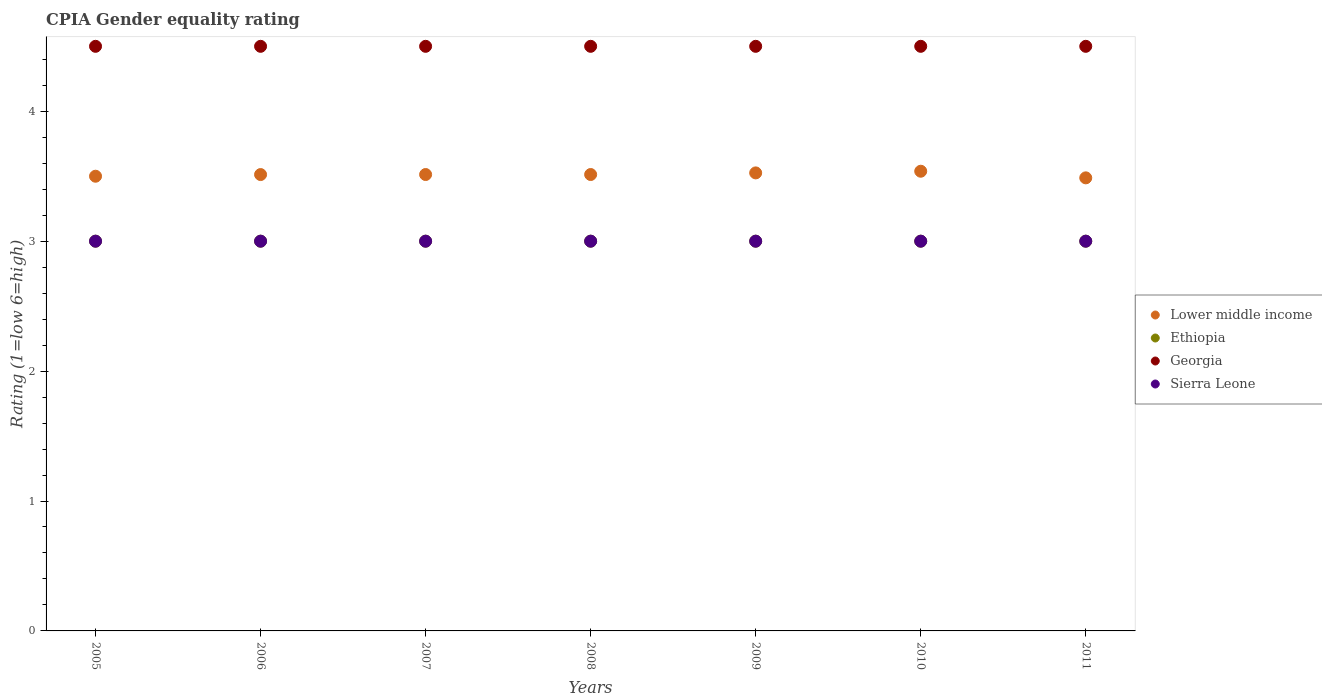Is the number of dotlines equal to the number of legend labels?
Offer a very short reply. Yes. What is the CPIA rating in Georgia in 2011?
Keep it short and to the point. 4.5. Across all years, what is the maximum CPIA rating in Georgia?
Your answer should be very brief. 4.5. In which year was the CPIA rating in Sierra Leone minimum?
Provide a succinct answer. 2005. What is the total CPIA rating in Georgia in the graph?
Give a very brief answer. 31.5. What is the difference between the CPIA rating in Lower middle income in 2005 and that in 2011?
Make the answer very short. 0.01. What is the difference between the CPIA rating in Lower middle income in 2006 and the CPIA rating in Sierra Leone in 2007?
Your response must be concise. 0.51. What is the average CPIA rating in Georgia per year?
Your answer should be compact. 4.5. In how many years, is the CPIA rating in Sierra Leone greater than 2.2?
Keep it short and to the point. 7. What is the ratio of the CPIA rating in Lower middle income in 2005 to that in 2011?
Give a very brief answer. 1. Is the CPIA rating in Georgia in 2007 less than that in 2011?
Your answer should be very brief. No. Is the difference between the CPIA rating in Sierra Leone in 2005 and 2010 greater than the difference between the CPIA rating in Lower middle income in 2005 and 2010?
Give a very brief answer. Yes. What is the difference between the highest and the lowest CPIA rating in Lower middle income?
Ensure brevity in your answer.  0.05. In how many years, is the CPIA rating in Ethiopia greater than the average CPIA rating in Ethiopia taken over all years?
Your response must be concise. 0. Is it the case that in every year, the sum of the CPIA rating in Sierra Leone and CPIA rating in Georgia  is greater than the CPIA rating in Ethiopia?
Ensure brevity in your answer.  Yes. Does the CPIA rating in Georgia monotonically increase over the years?
Ensure brevity in your answer.  No. Is the CPIA rating in Ethiopia strictly less than the CPIA rating in Sierra Leone over the years?
Your answer should be compact. No. How many dotlines are there?
Offer a terse response. 4. How many years are there in the graph?
Provide a succinct answer. 7. Where does the legend appear in the graph?
Ensure brevity in your answer.  Center right. How are the legend labels stacked?
Provide a short and direct response. Vertical. What is the title of the graph?
Your answer should be very brief. CPIA Gender equality rating. Does "Poland" appear as one of the legend labels in the graph?
Your response must be concise. No. What is the label or title of the X-axis?
Offer a very short reply. Years. What is the label or title of the Y-axis?
Offer a very short reply. Rating (1=low 6=high). What is the Rating (1=low 6=high) of Lower middle income in 2005?
Your answer should be very brief. 3.5. What is the Rating (1=low 6=high) of Georgia in 2005?
Offer a very short reply. 4.5. What is the Rating (1=low 6=high) of Sierra Leone in 2005?
Your answer should be compact. 3. What is the Rating (1=low 6=high) in Lower middle income in 2006?
Keep it short and to the point. 3.51. What is the Rating (1=low 6=high) in Ethiopia in 2006?
Your answer should be very brief. 3. What is the Rating (1=low 6=high) of Georgia in 2006?
Provide a short and direct response. 4.5. What is the Rating (1=low 6=high) of Lower middle income in 2007?
Provide a succinct answer. 3.51. What is the Rating (1=low 6=high) of Lower middle income in 2008?
Your answer should be compact. 3.51. What is the Rating (1=low 6=high) of Georgia in 2008?
Your answer should be very brief. 4.5. What is the Rating (1=low 6=high) of Sierra Leone in 2008?
Keep it short and to the point. 3. What is the Rating (1=low 6=high) in Lower middle income in 2009?
Offer a terse response. 3.53. What is the Rating (1=low 6=high) in Ethiopia in 2009?
Give a very brief answer. 3. What is the Rating (1=low 6=high) in Sierra Leone in 2009?
Give a very brief answer. 3. What is the Rating (1=low 6=high) in Lower middle income in 2010?
Give a very brief answer. 3.54. What is the Rating (1=low 6=high) in Lower middle income in 2011?
Your response must be concise. 3.49. What is the Rating (1=low 6=high) in Ethiopia in 2011?
Offer a terse response. 3. Across all years, what is the maximum Rating (1=low 6=high) of Lower middle income?
Provide a succinct answer. 3.54. Across all years, what is the maximum Rating (1=low 6=high) in Ethiopia?
Provide a short and direct response. 3. Across all years, what is the maximum Rating (1=low 6=high) in Sierra Leone?
Ensure brevity in your answer.  3. Across all years, what is the minimum Rating (1=low 6=high) of Lower middle income?
Provide a short and direct response. 3.49. What is the total Rating (1=low 6=high) in Lower middle income in the graph?
Offer a terse response. 24.59. What is the total Rating (1=low 6=high) of Georgia in the graph?
Make the answer very short. 31.5. What is the total Rating (1=low 6=high) in Sierra Leone in the graph?
Offer a terse response. 21. What is the difference between the Rating (1=low 6=high) of Lower middle income in 2005 and that in 2006?
Provide a short and direct response. -0.01. What is the difference between the Rating (1=low 6=high) of Ethiopia in 2005 and that in 2006?
Your answer should be compact. 0. What is the difference between the Rating (1=low 6=high) in Georgia in 2005 and that in 2006?
Provide a succinct answer. 0. What is the difference between the Rating (1=low 6=high) of Sierra Leone in 2005 and that in 2006?
Provide a short and direct response. 0. What is the difference between the Rating (1=low 6=high) in Lower middle income in 2005 and that in 2007?
Provide a succinct answer. -0.01. What is the difference between the Rating (1=low 6=high) in Sierra Leone in 2005 and that in 2007?
Your answer should be compact. 0. What is the difference between the Rating (1=low 6=high) in Lower middle income in 2005 and that in 2008?
Offer a terse response. -0.01. What is the difference between the Rating (1=low 6=high) of Ethiopia in 2005 and that in 2008?
Offer a very short reply. 0. What is the difference between the Rating (1=low 6=high) in Sierra Leone in 2005 and that in 2008?
Your answer should be very brief. 0. What is the difference between the Rating (1=low 6=high) in Lower middle income in 2005 and that in 2009?
Offer a very short reply. -0.03. What is the difference between the Rating (1=low 6=high) of Georgia in 2005 and that in 2009?
Provide a succinct answer. 0. What is the difference between the Rating (1=low 6=high) in Lower middle income in 2005 and that in 2010?
Provide a succinct answer. -0.04. What is the difference between the Rating (1=low 6=high) in Ethiopia in 2005 and that in 2010?
Offer a very short reply. 0. What is the difference between the Rating (1=low 6=high) in Georgia in 2005 and that in 2010?
Offer a terse response. 0. What is the difference between the Rating (1=low 6=high) in Lower middle income in 2005 and that in 2011?
Offer a very short reply. 0.01. What is the difference between the Rating (1=low 6=high) in Georgia in 2005 and that in 2011?
Your answer should be very brief. 0. What is the difference between the Rating (1=low 6=high) in Sierra Leone in 2005 and that in 2011?
Your response must be concise. 0. What is the difference between the Rating (1=low 6=high) of Lower middle income in 2006 and that in 2007?
Your answer should be compact. -0. What is the difference between the Rating (1=low 6=high) of Lower middle income in 2006 and that in 2008?
Your answer should be very brief. -0. What is the difference between the Rating (1=low 6=high) of Georgia in 2006 and that in 2008?
Make the answer very short. 0. What is the difference between the Rating (1=low 6=high) in Sierra Leone in 2006 and that in 2008?
Make the answer very short. 0. What is the difference between the Rating (1=low 6=high) in Lower middle income in 2006 and that in 2009?
Ensure brevity in your answer.  -0.01. What is the difference between the Rating (1=low 6=high) of Georgia in 2006 and that in 2009?
Provide a succinct answer. 0. What is the difference between the Rating (1=low 6=high) in Sierra Leone in 2006 and that in 2009?
Your answer should be very brief. 0. What is the difference between the Rating (1=low 6=high) in Lower middle income in 2006 and that in 2010?
Offer a terse response. -0.03. What is the difference between the Rating (1=low 6=high) in Ethiopia in 2006 and that in 2010?
Ensure brevity in your answer.  0. What is the difference between the Rating (1=low 6=high) in Sierra Leone in 2006 and that in 2010?
Offer a terse response. 0. What is the difference between the Rating (1=low 6=high) of Lower middle income in 2006 and that in 2011?
Make the answer very short. 0.03. What is the difference between the Rating (1=low 6=high) in Lower middle income in 2007 and that in 2008?
Make the answer very short. 0. What is the difference between the Rating (1=low 6=high) of Ethiopia in 2007 and that in 2008?
Offer a terse response. 0. What is the difference between the Rating (1=low 6=high) in Georgia in 2007 and that in 2008?
Offer a very short reply. 0. What is the difference between the Rating (1=low 6=high) of Sierra Leone in 2007 and that in 2008?
Make the answer very short. 0. What is the difference between the Rating (1=low 6=high) in Lower middle income in 2007 and that in 2009?
Keep it short and to the point. -0.01. What is the difference between the Rating (1=low 6=high) of Ethiopia in 2007 and that in 2009?
Make the answer very short. 0. What is the difference between the Rating (1=low 6=high) of Georgia in 2007 and that in 2009?
Offer a very short reply. 0. What is the difference between the Rating (1=low 6=high) in Sierra Leone in 2007 and that in 2009?
Provide a short and direct response. 0. What is the difference between the Rating (1=low 6=high) in Lower middle income in 2007 and that in 2010?
Your answer should be compact. -0.03. What is the difference between the Rating (1=low 6=high) in Ethiopia in 2007 and that in 2010?
Your answer should be very brief. 0. What is the difference between the Rating (1=low 6=high) in Georgia in 2007 and that in 2010?
Your answer should be compact. 0. What is the difference between the Rating (1=low 6=high) in Lower middle income in 2007 and that in 2011?
Offer a terse response. 0.03. What is the difference between the Rating (1=low 6=high) in Ethiopia in 2007 and that in 2011?
Offer a very short reply. 0. What is the difference between the Rating (1=low 6=high) in Sierra Leone in 2007 and that in 2011?
Your answer should be compact. 0. What is the difference between the Rating (1=low 6=high) in Lower middle income in 2008 and that in 2009?
Make the answer very short. -0.01. What is the difference between the Rating (1=low 6=high) in Ethiopia in 2008 and that in 2009?
Your response must be concise. 0. What is the difference between the Rating (1=low 6=high) of Lower middle income in 2008 and that in 2010?
Keep it short and to the point. -0.03. What is the difference between the Rating (1=low 6=high) in Ethiopia in 2008 and that in 2010?
Provide a succinct answer. 0. What is the difference between the Rating (1=low 6=high) in Sierra Leone in 2008 and that in 2010?
Provide a succinct answer. 0. What is the difference between the Rating (1=low 6=high) in Lower middle income in 2008 and that in 2011?
Keep it short and to the point. 0.03. What is the difference between the Rating (1=low 6=high) of Ethiopia in 2008 and that in 2011?
Provide a short and direct response. 0. What is the difference between the Rating (1=low 6=high) of Sierra Leone in 2008 and that in 2011?
Keep it short and to the point. 0. What is the difference between the Rating (1=low 6=high) in Lower middle income in 2009 and that in 2010?
Ensure brevity in your answer.  -0.01. What is the difference between the Rating (1=low 6=high) in Lower middle income in 2009 and that in 2011?
Your answer should be very brief. 0.04. What is the difference between the Rating (1=low 6=high) in Lower middle income in 2010 and that in 2011?
Your answer should be compact. 0.05. What is the difference between the Rating (1=low 6=high) in Georgia in 2010 and that in 2011?
Provide a short and direct response. 0. What is the difference between the Rating (1=low 6=high) of Sierra Leone in 2010 and that in 2011?
Provide a short and direct response. 0. What is the difference between the Rating (1=low 6=high) of Lower middle income in 2005 and the Rating (1=low 6=high) of Ethiopia in 2006?
Provide a succinct answer. 0.5. What is the difference between the Rating (1=low 6=high) of Lower middle income in 2005 and the Rating (1=low 6=high) of Georgia in 2006?
Provide a short and direct response. -1. What is the difference between the Rating (1=low 6=high) of Lower middle income in 2005 and the Rating (1=low 6=high) of Sierra Leone in 2006?
Offer a very short reply. 0.5. What is the difference between the Rating (1=low 6=high) in Ethiopia in 2005 and the Rating (1=low 6=high) in Georgia in 2006?
Offer a very short reply. -1.5. What is the difference between the Rating (1=low 6=high) of Ethiopia in 2005 and the Rating (1=low 6=high) of Sierra Leone in 2006?
Offer a terse response. 0. What is the difference between the Rating (1=low 6=high) of Georgia in 2005 and the Rating (1=low 6=high) of Sierra Leone in 2006?
Provide a short and direct response. 1.5. What is the difference between the Rating (1=low 6=high) of Ethiopia in 2005 and the Rating (1=low 6=high) of Georgia in 2007?
Give a very brief answer. -1.5. What is the difference between the Rating (1=low 6=high) in Ethiopia in 2005 and the Rating (1=low 6=high) in Sierra Leone in 2007?
Your answer should be very brief. 0. What is the difference between the Rating (1=low 6=high) of Georgia in 2005 and the Rating (1=low 6=high) of Sierra Leone in 2007?
Your response must be concise. 1.5. What is the difference between the Rating (1=low 6=high) of Lower middle income in 2005 and the Rating (1=low 6=high) of Ethiopia in 2008?
Keep it short and to the point. 0.5. What is the difference between the Rating (1=low 6=high) in Lower middle income in 2005 and the Rating (1=low 6=high) in Georgia in 2008?
Offer a very short reply. -1. What is the difference between the Rating (1=low 6=high) in Lower middle income in 2005 and the Rating (1=low 6=high) in Sierra Leone in 2008?
Offer a very short reply. 0.5. What is the difference between the Rating (1=low 6=high) of Ethiopia in 2005 and the Rating (1=low 6=high) of Sierra Leone in 2008?
Offer a terse response. 0. What is the difference between the Rating (1=low 6=high) in Georgia in 2005 and the Rating (1=low 6=high) in Sierra Leone in 2008?
Offer a very short reply. 1.5. What is the difference between the Rating (1=low 6=high) of Lower middle income in 2005 and the Rating (1=low 6=high) of Ethiopia in 2009?
Provide a short and direct response. 0.5. What is the difference between the Rating (1=low 6=high) of Lower middle income in 2005 and the Rating (1=low 6=high) of Georgia in 2009?
Keep it short and to the point. -1. What is the difference between the Rating (1=low 6=high) in Ethiopia in 2005 and the Rating (1=low 6=high) in Georgia in 2009?
Provide a short and direct response. -1.5. What is the difference between the Rating (1=low 6=high) in Ethiopia in 2005 and the Rating (1=low 6=high) in Sierra Leone in 2009?
Your answer should be compact. 0. What is the difference between the Rating (1=low 6=high) in Georgia in 2005 and the Rating (1=low 6=high) in Sierra Leone in 2009?
Your response must be concise. 1.5. What is the difference between the Rating (1=low 6=high) in Lower middle income in 2005 and the Rating (1=low 6=high) in Sierra Leone in 2010?
Offer a terse response. 0.5. What is the difference between the Rating (1=low 6=high) in Lower middle income in 2005 and the Rating (1=low 6=high) in Georgia in 2011?
Provide a short and direct response. -1. What is the difference between the Rating (1=low 6=high) of Lower middle income in 2005 and the Rating (1=low 6=high) of Sierra Leone in 2011?
Keep it short and to the point. 0.5. What is the difference between the Rating (1=low 6=high) of Ethiopia in 2005 and the Rating (1=low 6=high) of Georgia in 2011?
Ensure brevity in your answer.  -1.5. What is the difference between the Rating (1=low 6=high) in Ethiopia in 2005 and the Rating (1=low 6=high) in Sierra Leone in 2011?
Keep it short and to the point. 0. What is the difference between the Rating (1=low 6=high) in Lower middle income in 2006 and the Rating (1=low 6=high) in Ethiopia in 2007?
Keep it short and to the point. 0.51. What is the difference between the Rating (1=low 6=high) in Lower middle income in 2006 and the Rating (1=low 6=high) in Georgia in 2007?
Offer a very short reply. -0.99. What is the difference between the Rating (1=low 6=high) in Lower middle income in 2006 and the Rating (1=low 6=high) in Sierra Leone in 2007?
Give a very brief answer. 0.51. What is the difference between the Rating (1=low 6=high) of Ethiopia in 2006 and the Rating (1=low 6=high) of Georgia in 2007?
Make the answer very short. -1.5. What is the difference between the Rating (1=low 6=high) of Ethiopia in 2006 and the Rating (1=low 6=high) of Sierra Leone in 2007?
Provide a succinct answer. 0. What is the difference between the Rating (1=low 6=high) of Georgia in 2006 and the Rating (1=low 6=high) of Sierra Leone in 2007?
Keep it short and to the point. 1.5. What is the difference between the Rating (1=low 6=high) of Lower middle income in 2006 and the Rating (1=low 6=high) of Ethiopia in 2008?
Provide a short and direct response. 0.51. What is the difference between the Rating (1=low 6=high) of Lower middle income in 2006 and the Rating (1=low 6=high) of Georgia in 2008?
Provide a short and direct response. -0.99. What is the difference between the Rating (1=low 6=high) of Lower middle income in 2006 and the Rating (1=low 6=high) of Sierra Leone in 2008?
Your answer should be very brief. 0.51. What is the difference between the Rating (1=low 6=high) of Ethiopia in 2006 and the Rating (1=low 6=high) of Georgia in 2008?
Your response must be concise. -1.5. What is the difference between the Rating (1=low 6=high) in Ethiopia in 2006 and the Rating (1=low 6=high) in Sierra Leone in 2008?
Offer a terse response. 0. What is the difference between the Rating (1=low 6=high) of Lower middle income in 2006 and the Rating (1=low 6=high) of Ethiopia in 2009?
Your response must be concise. 0.51. What is the difference between the Rating (1=low 6=high) of Lower middle income in 2006 and the Rating (1=low 6=high) of Georgia in 2009?
Offer a terse response. -0.99. What is the difference between the Rating (1=low 6=high) of Lower middle income in 2006 and the Rating (1=low 6=high) of Sierra Leone in 2009?
Offer a very short reply. 0.51. What is the difference between the Rating (1=low 6=high) of Ethiopia in 2006 and the Rating (1=low 6=high) of Georgia in 2009?
Your response must be concise. -1.5. What is the difference between the Rating (1=low 6=high) of Lower middle income in 2006 and the Rating (1=low 6=high) of Ethiopia in 2010?
Provide a succinct answer. 0.51. What is the difference between the Rating (1=low 6=high) of Lower middle income in 2006 and the Rating (1=low 6=high) of Georgia in 2010?
Offer a terse response. -0.99. What is the difference between the Rating (1=low 6=high) of Lower middle income in 2006 and the Rating (1=low 6=high) of Sierra Leone in 2010?
Your answer should be compact. 0.51. What is the difference between the Rating (1=low 6=high) of Georgia in 2006 and the Rating (1=low 6=high) of Sierra Leone in 2010?
Give a very brief answer. 1.5. What is the difference between the Rating (1=low 6=high) in Lower middle income in 2006 and the Rating (1=low 6=high) in Ethiopia in 2011?
Make the answer very short. 0.51. What is the difference between the Rating (1=low 6=high) of Lower middle income in 2006 and the Rating (1=low 6=high) of Georgia in 2011?
Make the answer very short. -0.99. What is the difference between the Rating (1=low 6=high) in Lower middle income in 2006 and the Rating (1=low 6=high) in Sierra Leone in 2011?
Make the answer very short. 0.51. What is the difference between the Rating (1=low 6=high) of Ethiopia in 2006 and the Rating (1=low 6=high) of Georgia in 2011?
Your response must be concise. -1.5. What is the difference between the Rating (1=low 6=high) in Ethiopia in 2006 and the Rating (1=low 6=high) in Sierra Leone in 2011?
Offer a very short reply. 0. What is the difference between the Rating (1=low 6=high) of Georgia in 2006 and the Rating (1=low 6=high) of Sierra Leone in 2011?
Your response must be concise. 1.5. What is the difference between the Rating (1=low 6=high) in Lower middle income in 2007 and the Rating (1=low 6=high) in Ethiopia in 2008?
Keep it short and to the point. 0.51. What is the difference between the Rating (1=low 6=high) in Lower middle income in 2007 and the Rating (1=low 6=high) in Georgia in 2008?
Ensure brevity in your answer.  -0.99. What is the difference between the Rating (1=low 6=high) of Lower middle income in 2007 and the Rating (1=low 6=high) of Sierra Leone in 2008?
Ensure brevity in your answer.  0.51. What is the difference between the Rating (1=low 6=high) of Georgia in 2007 and the Rating (1=low 6=high) of Sierra Leone in 2008?
Offer a terse response. 1.5. What is the difference between the Rating (1=low 6=high) of Lower middle income in 2007 and the Rating (1=low 6=high) of Ethiopia in 2009?
Your response must be concise. 0.51. What is the difference between the Rating (1=low 6=high) in Lower middle income in 2007 and the Rating (1=low 6=high) in Georgia in 2009?
Provide a short and direct response. -0.99. What is the difference between the Rating (1=low 6=high) of Lower middle income in 2007 and the Rating (1=low 6=high) of Sierra Leone in 2009?
Your answer should be very brief. 0.51. What is the difference between the Rating (1=low 6=high) of Lower middle income in 2007 and the Rating (1=low 6=high) of Ethiopia in 2010?
Keep it short and to the point. 0.51. What is the difference between the Rating (1=low 6=high) in Lower middle income in 2007 and the Rating (1=low 6=high) in Georgia in 2010?
Make the answer very short. -0.99. What is the difference between the Rating (1=low 6=high) in Lower middle income in 2007 and the Rating (1=low 6=high) in Sierra Leone in 2010?
Ensure brevity in your answer.  0.51. What is the difference between the Rating (1=low 6=high) in Ethiopia in 2007 and the Rating (1=low 6=high) in Georgia in 2010?
Your answer should be very brief. -1.5. What is the difference between the Rating (1=low 6=high) in Georgia in 2007 and the Rating (1=low 6=high) in Sierra Leone in 2010?
Make the answer very short. 1.5. What is the difference between the Rating (1=low 6=high) in Lower middle income in 2007 and the Rating (1=low 6=high) in Ethiopia in 2011?
Offer a terse response. 0.51. What is the difference between the Rating (1=low 6=high) of Lower middle income in 2007 and the Rating (1=low 6=high) of Georgia in 2011?
Provide a short and direct response. -0.99. What is the difference between the Rating (1=low 6=high) in Lower middle income in 2007 and the Rating (1=low 6=high) in Sierra Leone in 2011?
Provide a short and direct response. 0.51. What is the difference between the Rating (1=low 6=high) of Ethiopia in 2007 and the Rating (1=low 6=high) of Georgia in 2011?
Your response must be concise. -1.5. What is the difference between the Rating (1=low 6=high) of Ethiopia in 2007 and the Rating (1=low 6=high) of Sierra Leone in 2011?
Make the answer very short. 0. What is the difference between the Rating (1=low 6=high) in Georgia in 2007 and the Rating (1=low 6=high) in Sierra Leone in 2011?
Provide a short and direct response. 1.5. What is the difference between the Rating (1=low 6=high) in Lower middle income in 2008 and the Rating (1=low 6=high) in Ethiopia in 2009?
Ensure brevity in your answer.  0.51. What is the difference between the Rating (1=low 6=high) of Lower middle income in 2008 and the Rating (1=low 6=high) of Georgia in 2009?
Keep it short and to the point. -0.99. What is the difference between the Rating (1=low 6=high) of Lower middle income in 2008 and the Rating (1=low 6=high) of Sierra Leone in 2009?
Keep it short and to the point. 0.51. What is the difference between the Rating (1=low 6=high) of Ethiopia in 2008 and the Rating (1=low 6=high) of Georgia in 2009?
Provide a succinct answer. -1.5. What is the difference between the Rating (1=low 6=high) of Ethiopia in 2008 and the Rating (1=low 6=high) of Sierra Leone in 2009?
Keep it short and to the point. 0. What is the difference between the Rating (1=low 6=high) of Lower middle income in 2008 and the Rating (1=low 6=high) of Ethiopia in 2010?
Provide a succinct answer. 0.51. What is the difference between the Rating (1=low 6=high) of Lower middle income in 2008 and the Rating (1=low 6=high) of Georgia in 2010?
Offer a terse response. -0.99. What is the difference between the Rating (1=low 6=high) in Lower middle income in 2008 and the Rating (1=low 6=high) in Sierra Leone in 2010?
Keep it short and to the point. 0.51. What is the difference between the Rating (1=low 6=high) in Georgia in 2008 and the Rating (1=low 6=high) in Sierra Leone in 2010?
Offer a terse response. 1.5. What is the difference between the Rating (1=low 6=high) in Lower middle income in 2008 and the Rating (1=low 6=high) in Ethiopia in 2011?
Give a very brief answer. 0.51. What is the difference between the Rating (1=low 6=high) of Lower middle income in 2008 and the Rating (1=low 6=high) of Georgia in 2011?
Offer a terse response. -0.99. What is the difference between the Rating (1=low 6=high) of Lower middle income in 2008 and the Rating (1=low 6=high) of Sierra Leone in 2011?
Keep it short and to the point. 0.51. What is the difference between the Rating (1=low 6=high) of Lower middle income in 2009 and the Rating (1=low 6=high) of Ethiopia in 2010?
Your response must be concise. 0.53. What is the difference between the Rating (1=low 6=high) in Lower middle income in 2009 and the Rating (1=low 6=high) in Georgia in 2010?
Provide a succinct answer. -0.97. What is the difference between the Rating (1=low 6=high) of Lower middle income in 2009 and the Rating (1=low 6=high) of Sierra Leone in 2010?
Provide a short and direct response. 0.53. What is the difference between the Rating (1=low 6=high) of Ethiopia in 2009 and the Rating (1=low 6=high) of Georgia in 2010?
Ensure brevity in your answer.  -1.5. What is the difference between the Rating (1=low 6=high) of Georgia in 2009 and the Rating (1=low 6=high) of Sierra Leone in 2010?
Your answer should be compact. 1.5. What is the difference between the Rating (1=low 6=high) in Lower middle income in 2009 and the Rating (1=low 6=high) in Ethiopia in 2011?
Keep it short and to the point. 0.53. What is the difference between the Rating (1=low 6=high) in Lower middle income in 2009 and the Rating (1=low 6=high) in Georgia in 2011?
Keep it short and to the point. -0.97. What is the difference between the Rating (1=low 6=high) of Lower middle income in 2009 and the Rating (1=low 6=high) of Sierra Leone in 2011?
Keep it short and to the point. 0.53. What is the difference between the Rating (1=low 6=high) in Ethiopia in 2009 and the Rating (1=low 6=high) in Georgia in 2011?
Keep it short and to the point. -1.5. What is the difference between the Rating (1=low 6=high) in Lower middle income in 2010 and the Rating (1=low 6=high) in Ethiopia in 2011?
Your response must be concise. 0.54. What is the difference between the Rating (1=low 6=high) of Lower middle income in 2010 and the Rating (1=low 6=high) of Georgia in 2011?
Your answer should be very brief. -0.96. What is the difference between the Rating (1=low 6=high) in Lower middle income in 2010 and the Rating (1=low 6=high) in Sierra Leone in 2011?
Provide a short and direct response. 0.54. What is the difference between the Rating (1=low 6=high) in Georgia in 2010 and the Rating (1=low 6=high) in Sierra Leone in 2011?
Your answer should be compact. 1.5. What is the average Rating (1=low 6=high) in Lower middle income per year?
Your answer should be very brief. 3.51. What is the average Rating (1=low 6=high) in Ethiopia per year?
Your answer should be very brief. 3. What is the average Rating (1=low 6=high) in Georgia per year?
Your answer should be very brief. 4.5. In the year 2005, what is the difference between the Rating (1=low 6=high) in Lower middle income and Rating (1=low 6=high) in Ethiopia?
Ensure brevity in your answer.  0.5. In the year 2005, what is the difference between the Rating (1=low 6=high) of Lower middle income and Rating (1=low 6=high) of Georgia?
Provide a succinct answer. -1. In the year 2005, what is the difference between the Rating (1=low 6=high) of Lower middle income and Rating (1=low 6=high) of Sierra Leone?
Offer a terse response. 0.5. In the year 2005, what is the difference between the Rating (1=low 6=high) of Ethiopia and Rating (1=low 6=high) of Sierra Leone?
Offer a very short reply. 0. In the year 2006, what is the difference between the Rating (1=low 6=high) in Lower middle income and Rating (1=low 6=high) in Ethiopia?
Your response must be concise. 0.51. In the year 2006, what is the difference between the Rating (1=low 6=high) in Lower middle income and Rating (1=low 6=high) in Georgia?
Give a very brief answer. -0.99. In the year 2006, what is the difference between the Rating (1=low 6=high) of Lower middle income and Rating (1=low 6=high) of Sierra Leone?
Your answer should be compact. 0.51. In the year 2006, what is the difference between the Rating (1=low 6=high) in Ethiopia and Rating (1=low 6=high) in Georgia?
Offer a very short reply. -1.5. In the year 2006, what is the difference between the Rating (1=low 6=high) of Ethiopia and Rating (1=low 6=high) of Sierra Leone?
Your answer should be compact. 0. In the year 2007, what is the difference between the Rating (1=low 6=high) in Lower middle income and Rating (1=low 6=high) in Ethiopia?
Provide a succinct answer. 0.51. In the year 2007, what is the difference between the Rating (1=low 6=high) of Lower middle income and Rating (1=low 6=high) of Georgia?
Make the answer very short. -0.99. In the year 2007, what is the difference between the Rating (1=low 6=high) of Lower middle income and Rating (1=low 6=high) of Sierra Leone?
Your answer should be compact. 0.51. In the year 2007, what is the difference between the Rating (1=low 6=high) in Ethiopia and Rating (1=low 6=high) in Georgia?
Your response must be concise. -1.5. In the year 2007, what is the difference between the Rating (1=low 6=high) of Georgia and Rating (1=low 6=high) of Sierra Leone?
Make the answer very short. 1.5. In the year 2008, what is the difference between the Rating (1=low 6=high) of Lower middle income and Rating (1=low 6=high) of Ethiopia?
Provide a short and direct response. 0.51. In the year 2008, what is the difference between the Rating (1=low 6=high) of Lower middle income and Rating (1=low 6=high) of Georgia?
Make the answer very short. -0.99. In the year 2008, what is the difference between the Rating (1=low 6=high) in Lower middle income and Rating (1=low 6=high) in Sierra Leone?
Provide a short and direct response. 0.51. In the year 2008, what is the difference between the Rating (1=low 6=high) in Georgia and Rating (1=low 6=high) in Sierra Leone?
Make the answer very short. 1.5. In the year 2009, what is the difference between the Rating (1=low 6=high) in Lower middle income and Rating (1=low 6=high) in Ethiopia?
Your answer should be compact. 0.53. In the year 2009, what is the difference between the Rating (1=low 6=high) in Lower middle income and Rating (1=low 6=high) in Georgia?
Your answer should be very brief. -0.97. In the year 2009, what is the difference between the Rating (1=low 6=high) of Lower middle income and Rating (1=low 6=high) of Sierra Leone?
Offer a terse response. 0.53. In the year 2009, what is the difference between the Rating (1=low 6=high) of Ethiopia and Rating (1=low 6=high) of Georgia?
Your answer should be compact. -1.5. In the year 2009, what is the difference between the Rating (1=low 6=high) in Ethiopia and Rating (1=low 6=high) in Sierra Leone?
Your response must be concise. 0. In the year 2009, what is the difference between the Rating (1=low 6=high) in Georgia and Rating (1=low 6=high) in Sierra Leone?
Your answer should be very brief. 1.5. In the year 2010, what is the difference between the Rating (1=low 6=high) of Lower middle income and Rating (1=low 6=high) of Ethiopia?
Keep it short and to the point. 0.54. In the year 2010, what is the difference between the Rating (1=low 6=high) in Lower middle income and Rating (1=low 6=high) in Georgia?
Make the answer very short. -0.96. In the year 2010, what is the difference between the Rating (1=low 6=high) in Lower middle income and Rating (1=low 6=high) in Sierra Leone?
Ensure brevity in your answer.  0.54. In the year 2010, what is the difference between the Rating (1=low 6=high) in Ethiopia and Rating (1=low 6=high) in Georgia?
Provide a short and direct response. -1.5. In the year 2010, what is the difference between the Rating (1=low 6=high) of Ethiopia and Rating (1=low 6=high) of Sierra Leone?
Offer a very short reply. 0. In the year 2011, what is the difference between the Rating (1=low 6=high) of Lower middle income and Rating (1=low 6=high) of Ethiopia?
Make the answer very short. 0.49. In the year 2011, what is the difference between the Rating (1=low 6=high) in Lower middle income and Rating (1=low 6=high) in Georgia?
Provide a short and direct response. -1.01. In the year 2011, what is the difference between the Rating (1=low 6=high) in Lower middle income and Rating (1=low 6=high) in Sierra Leone?
Give a very brief answer. 0.49. In the year 2011, what is the difference between the Rating (1=low 6=high) of Ethiopia and Rating (1=low 6=high) of Sierra Leone?
Provide a short and direct response. 0. What is the ratio of the Rating (1=low 6=high) in Lower middle income in 2005 to that in 2006?
Offer a very short reply. 1. What is the ratio of the Rating (1=low 6=high) in Ethiopia in 2005 to that in 2006?
Offer a very short reply. 1. What is the ratio of the Rating (1=low 6=high) of Georgia in 2005 to that in 2006?
Keep it short and to the point. 1. What is the ratio of the Rating (1=low 6=high) of Sierra Leone in 2005 to that in 2006?
Your answer should be very brief. 1. What is the ratio of the Rating (1=low 6=high) in Lower middle income in 2005 to that in 2007?
Ensure brevity in your answer.  1. What is the ratio of the Rating (1=low 6=high) of Ethiopia in 2005 to that in 2007?
Offer a very short reply. 1. What is the ratio of the Rating (1=low 6=high) of Georgia in 2005 to that in 2007?
Your answer should be compact. 1. What is the ratio of the Rating (1=low 6=high) of Ethiopia in 2005 to that in 2008?
Your answer should be very brief. 1. What is the ratio of the Rating (1=low 6=high) in Sierra Leone in 2005 to that in 2008?
Your answer should be compact. 1. What is the ratio of the Rating (1=low 6=high) of Ethiopia in 2005 to that in 2009?
Give a very brief answer. 1. What is the ratio of the Rating (1=low 6=high) of Georgia in 2005 to that in 2009?
Your response must be concise. 1. What is the ratio of the Rating (1=low 6=high) of Sierra Leone in 2005 to that in 2009?
Your answer should be compact. 1. What is the ratio of the Rating (1=low 6=high) of Lower middle income in 2005 to that in 2010?
Offer a very short reply. 0.99. What is the ratio of the Rating (1=low 6=high) in Sierra Leone in 2005 to that in 2010?
Provide a short and direct response. 1. What is the ratio of the Rating (1=low 6=high) in Lower middle income in 2005 to that in 2011?
Provide a succinct answer. 1. What is the ratio of the Rating (1=low 6=high) of Georgia in 2005 to that in 2011?
Offer a terse response. 1. What is the ratio of the Rating (1=low 6=high) of Sierra Leone in 2005 to that in 2011?
Your answer should be compact. 1. What is the ratio of the Rating (1=low 6=high) in Georgia in 2006 to that in 2007?
Your answer should be very brief. 1. What is the ratio of the Rating (1=low 6=high) of Sierra Leone in 2006 to that in 2007?
Your answer should be very brief. 1. What is the ratio of the Rating (1=low 6=high) in Lower middle income in 2006 to that in 2008?
Keep it short and to the point. 1. What is the ratio of the Rating (1=low 6=high) of Ethiopia in 2006 to that in 2008?
Provide a succinct answer. 1. What is the ratio of the Rating (1=low 6=high) in Sierra Leone in 2006 to that in 2008?
Provide a succinct answer. 1. What is the ratio of the Rating (1=low 6=high) of Lower middle income in 2006 to that in 2009?
Your response must be concise. 1. What is the ratio of the Rating (1=low 6=high) in Ethiopia in 2006 to that in 2009?
Provide a succinct answer. 1. What is the ratio of the Rating (1=low 6=high) of Georgia in 2006 to that in 2009?
Your answer should be very brief. 1. What is the ratio of the Rating (1=low 6=high) in Sierra Leone in 2006 to that in 2009?
Your answer should be compact. 1. What is the ratio of the Rating (1=low 6=high) in Lower middle income in 2006 to that in 2010?
Offer a very short reply. 0.99. What is the ratio of the Rating (1=low 6=high) in Ethiopia in 2006 to that in 2010?
Your response must be concise. 1. What is the ratio of the Rating (1=low 6=high) of Lower middle income in 2006 to that in 2011?
Offer a very short reply. 1.01. What is the ratio of the Rating (1=low 6=high) of Georgia in 2006 to that in 2011?
Your response must be concise. 1. What is the ratio of the Rating (1=low 6=high) of Ethiopia in 2007 to that in 2008?
Provide a short and direct response. 1. What is the ratio of the Rating (1=low 6=high) in Sierra Leone in 2007 to that in 2008?
Make the answer very short. 1. What is the ratio of the Rating (1=low 6=high) of Lower middle income in 2007 to that in 2009?
Ensure brevity in your answer.  1. What is the ratio of the Rating (1=low 6=high) of Ethiopia in 2007 to that in 2009?
Your answer should be compact. 1. What is the ratio of the Rating (1=low 6=high) in Georgia in 2007 to that in 2009?
Offer a terse response. 1. What is the ratio of the Rating (1=low 6=high) in Lower middle income in 2007 to that in 2010?
Keep it short and to the point. 0.99. What is the ratio of the Rating (1=low 6=high) in Ethiopia in 2007 to that in 2010?
Keep it short and to the point. 1. What is the ratio of the Rating (1=low 6=high) of Sierra Leone in 2007 to that in 2010?
Provide a succinct answer. 1. What is the ratio of the Rating (1=low 6=high) in Lower middle income in 2007 to that in 2011?
Give a very brief answer. 1.01. What is the ratio of the Rating (1=low 6=high) in Lower middle income in 2008 to that in 2009?
Make the answer very short. 1. What is the ratio of the Rating (1=low 6=high) in Ethiopia in 2008 to that in 2009?
Provide a succinct answer. 1. What is the ratio of the Rating (1=low 6=high) of Georgia in 2008 to that in 2009?
Offer a very short reply. 1. What is the ratio of the Rating (1=low 6=high) in Lower middle income in 2008 to that in 2010?
Your answer should be compact. 0.99. What is the ratio of the Rating (1=low 6=high) in Sierra Leone in 2008 to that in 2010?
Your answer should be compact. 1. What is the ratio of the Rating (1=low 6=high) of Lower middle income in 2008 to that in 2011?
Ensure brevity in your answer.  1.01. What is the ratio of the Rating (1=low 6=high) in Lower middle income in 2009 to that in 2011?
Offer a very short reply. 1.01. What is the ratio of the Rating (1=low 6=high) in Lower middle income in 2010 to that in 2011?
Offer a terse response. 1.01. What is the ratio of the Rating (1=low 6=high) of Ethiopia in 2010 to that in 2011?
Offer a terse response. 1. What is the ratio of the Rating (1=low 6=high) in Georgia in 2010 to that in 2011?
Offer a very short reply. 1. What is the ratio of the Rating (1=low 6=high) of Sierra Leone in 2010 to that in 2011?
Offer a very short reply. 1. What is the difference between the highest and the second highest Rating (1=low 6=high) of Lower middle income?
Your response must be concise. 0.01. What is the difference between the highest and the second highest Rating (1=low 6=high) of Ethiopia?
Your response must be concise. 0. What is the difference between the highest and the second highest Rating (1=low 6=high) of Georgia?
Make the answer very short. 0. What is the difference between the highest and the lowest Rating (1=low 6=high) in Lower middle income?
Your answer should be compact. 0.05. What is the difference between the highest and the lowest Rating (1=low 6=high) of Ethiopia?
Your response must be concise. 0. What is the difference between the highest and the lowest Rating (1=low 6=high) in Georgia?
Give a very brief answer. 0. What is the difference between the highest and the lowest Rating (1=low 6=high) of Sierra Leone?
Keep it short and to the point. 0. 